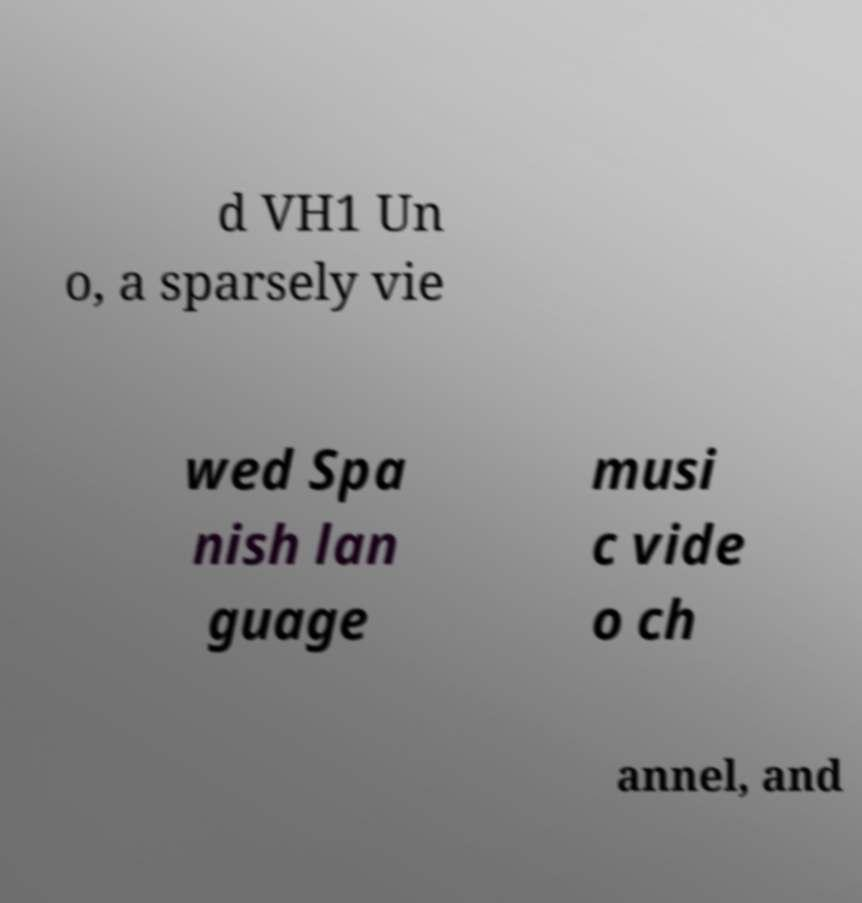For documentation purposes, I need the text within this image transcribed. Could you provide that? d VH1 Un o, a sparsely vie wed Spa nish lan guage musi c vide o ch annel, and 